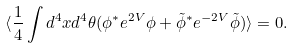<formula> <loc_0><loc_0><loc_500><loc_500>\langle \frac { 1 } { 4 } \int d ^ { 4 } x d ^ { 4 } \theta ( \phi ^ { * } e ^ { 2 V } \phi + \tilde { \phi } ^ { * } e ^ { - 2 V } \tilde { \phi } ) \rangle = 0 .</formula> 